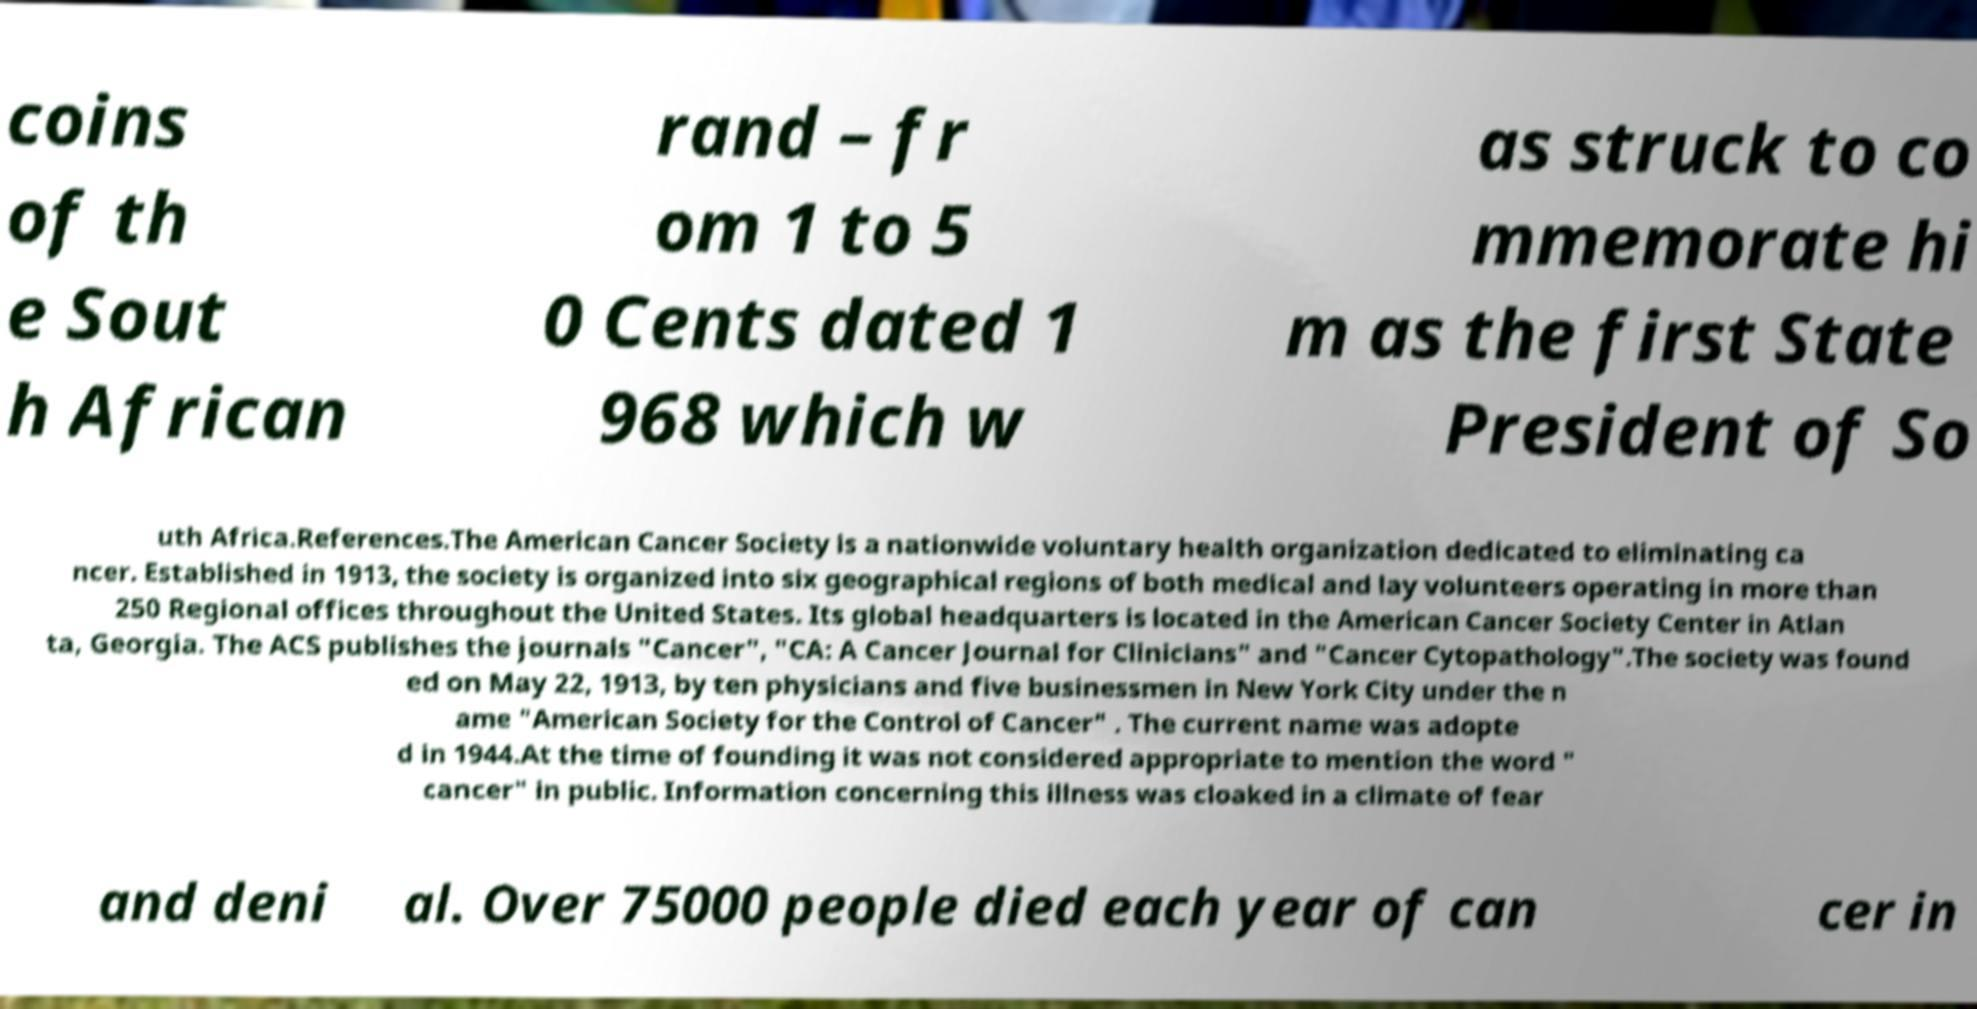Please identify and transcribe the text found in this image. coins of th e Sout h African rand – fr om 1 to 5 0 Cents dated 1 968 which w as struck to co mmemorate hi m as the first State President of So uth Africa.References.The American Cancer Society is a nationwide voluntary health organization dedicated to eliminating ca ncer. Established in 1913, the society is organized into six geographical regions of both medical and lay volunteers operating in more than 250 Regional offices throughout the United States. Its global headquarters is located in the American Cancer Society Center in Atlan ta, Georgia. The ACS publishes the journals "Cancer", "CA: A Cancer Journal for Clinicians" and "Cancer Cytopathology".The society was found ed on May 22, 1913, by ten physicians and five businessmen in New York City under the n ame "American Society for the Control of Cancer" . The current name was adopte d in 1944.At the time of founding it was not considered appropriate to mention the word " cancer" in public. Information concerning this illness was cloaked in a climate of fear and deni al. Over 75000 people died each year of can cer in 